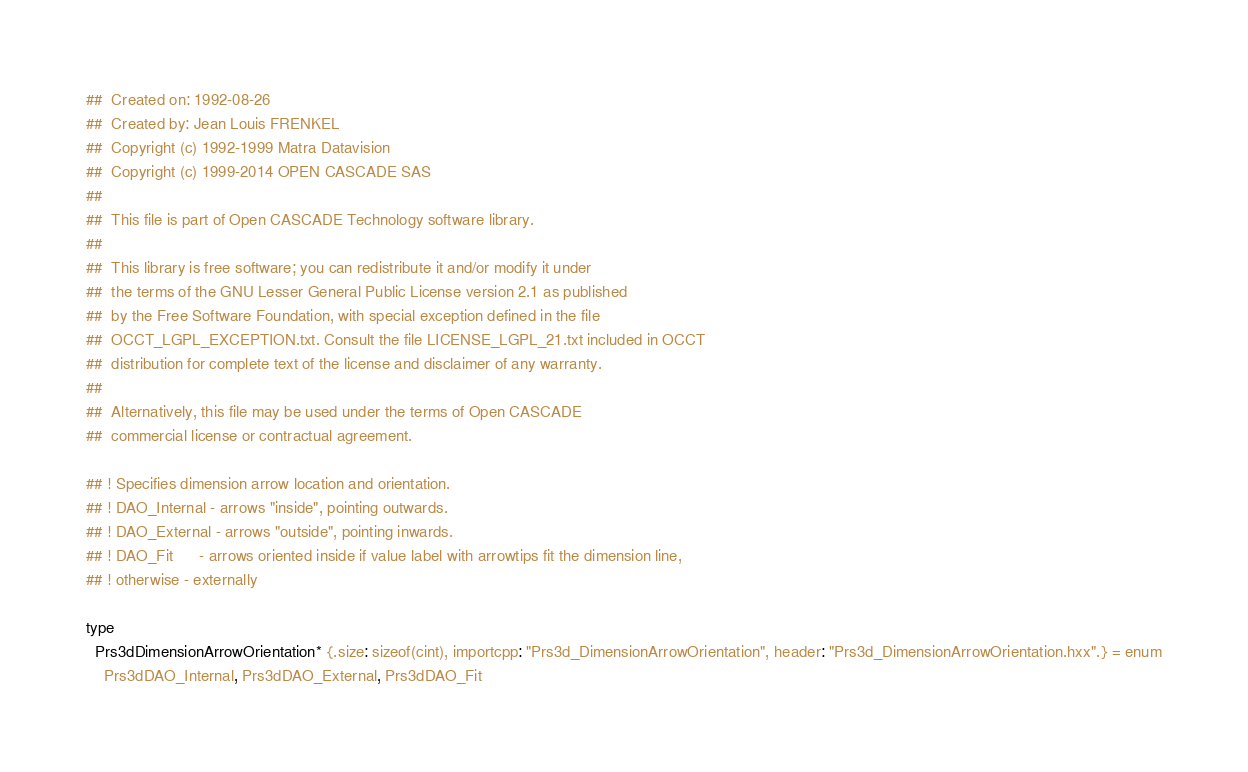<code> <loc_0><loc_0><loc_500><loc_500><_Nim_>##  Created on: 1992-08-26
##  Created by: Jean Louis FRENKEL
##  Copyright (c) 1992-1999 Matra Datavision
##  Copyright (c) 1999-2014 OPEN CASCADE SAS
##
##  This file is part of Open CASCADE Technology software library.
##
##  This library is free software; you can redistribute it and/or modify it under
##  the terms of the GNU Lesser General Public License version 2.1 as published
##  by the Free Software Foundation, with special exception defined in the file
##  OCCT_LGPL_EXCEPTION.txt. Consult the file LICENSE_LGPL_21.txt included in OCCT
##  distribution for complete text of the license and disclaimer of any warranty.
##
##  Alternatively, this file may be used under the terms of Open CASCADE
##  commercial license or contractual agreement.

## ! Specifies dimension arrow location and orientation.
## ! DAO_Internal - arrows "inside", pointing outwards.
## ! DAO_External - arrows "outside", pointing inwards.
## ! DAO_Fit      - arrows oriented inside if value label with arrowtips fit the dimension line,
## ! otherwise - externally

type
  Prs3dDimensionArrowOrientation* {.size: sizeof(cint), importcpp: "Prs3d_DimensionArrowOrientation", header: "Prs3d_DimensionArrowOrientation.hxx".} = enum
    Prs3dDAO_Internal, Prs3dDAO_External, Prs3dDAO_Fit

</code> 